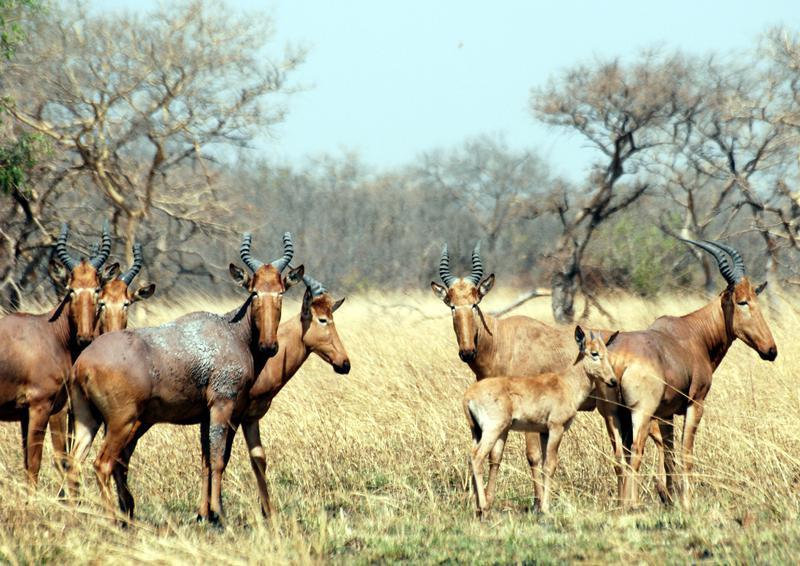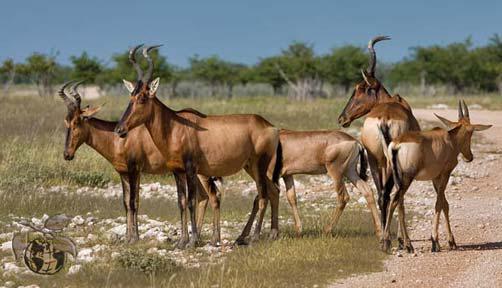The first image is the image on the left, the second image is the image on the right. Examine the images to the left and right. Is the description "An image shows a group of five antelope type animals." accurate? Answer yes or no. Yes. The first image is the image on the left, the second image is the image on the right. Given the left and right images, does the statement "There are 5 antelopes in the right most image." hold true? Answer yes or no. Yes. 